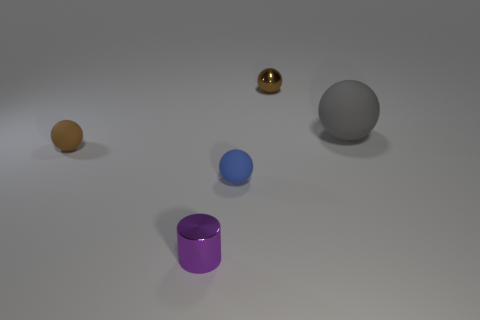Imagine these objects being part of a child's playset. Can you describe a potential game a child could play with these? Certainly! A child could play a sorting game, categorizing the objects by size and color. Another game could involve using imagination to assign roles to each object, such as representing planet spheres in a galaxy or pieces in an abstract sculpture, promoting creative storytelling and role-playing. 